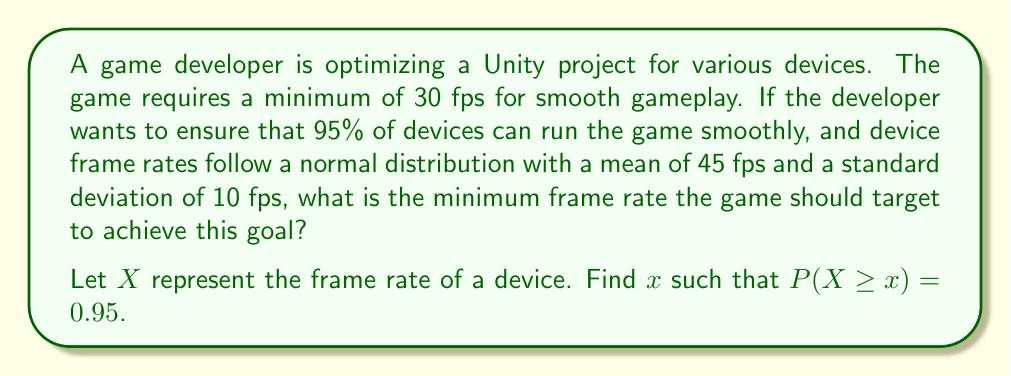Teach me how to tackle this problem. To solve this problem, we'll follow these steps:

1) We're dealing with a normal distribution where:
   $\mu = 45$ fps (mean)
   $\sigma = 10$ fps (standard deviation)

2) We need to find $x$ where $P(X \geq x) = 0.95$, which is equivalent to $P(X < x) = 0.05$

3) For a normal distribution, we can use the z-score formula:
   $z = \frac{x - \mu}{\sigma}$

4) We need to find the z-score that corresponds to a left-tail probability of 0.05. From a standard normal distribution table or calculator, we find:
   $z \approx -1.645$

5) Now we can use the z-score formula to solve for $x$:
   
   $$-1.645 = \frac{x - 45}{10}$$

6) Multiply both sides by 10:
   
   $$-16.45 = x - 45$$

7) Add 45 to both sides:
   
   $$28.55 = x$$

8) Round up to the nearest whole number, as frame rates are typically integers:
   
   $$x = 29$$

Therefore, the game should target a minimum frame rate of 29 fps to ensure smooth gameplay on 95% of devices.
Answer: 29 fps 